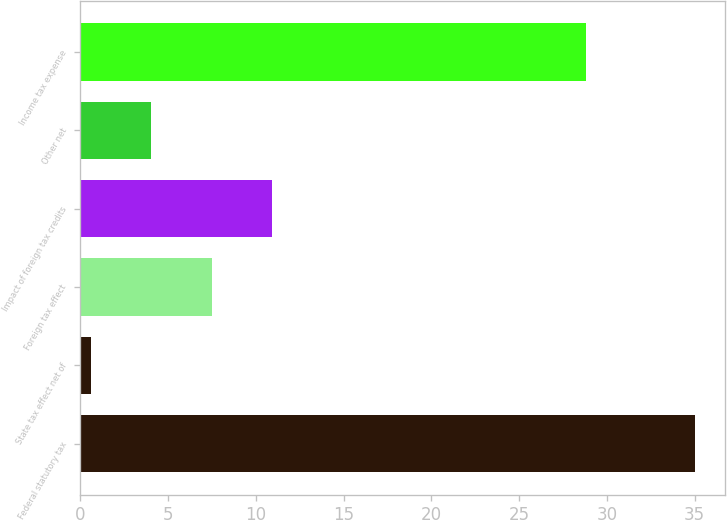<chart> <loc_0><loc_0><loc_500><loc_500><bar_chart><fcel>Federal statutory tax<fcel>State tax effect net of<fcel>Foreign tax effect<fcel>Impact of foreign tax credits<fcel>Other net<fcel>Income tax expense<nl><fcel>35<fcel>0.6<fcel>7.48<fcel>10.92<fcel>4.04<fcel>28.8<nl></chart> 